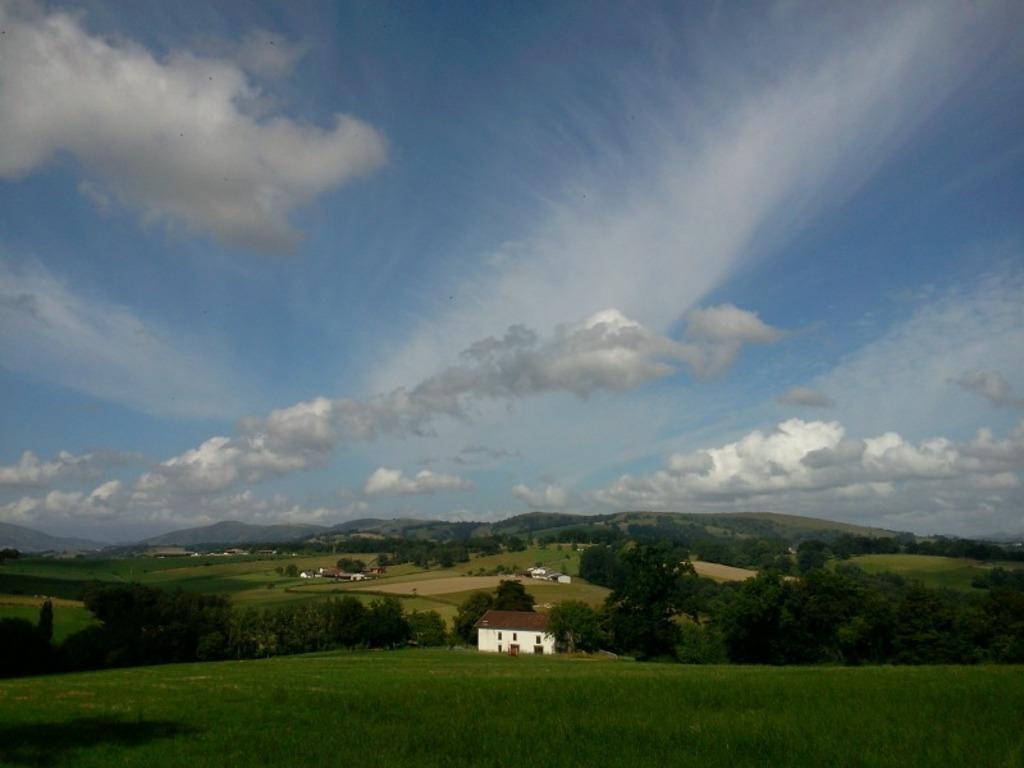Describe this image in one or two sentences. In this image I can see houses and trees. We can see garden in front. Back I can see mountains. The sky is in blue and white color. 